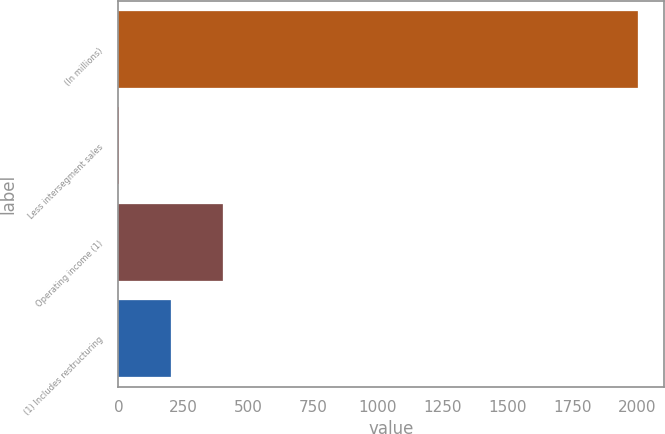Convert chart to OTSL. <chart><loc_0><loc_0><loc_500><loc_500><bar_chart><fcel>(In millions)<fcel>Less intersegment sales<fcel>Operating income (1)<fcel>(1) Includes restructuring<nl><fcel>2005<fcel>2<fcel>402.6<fcel>202.3<nl></chart> 